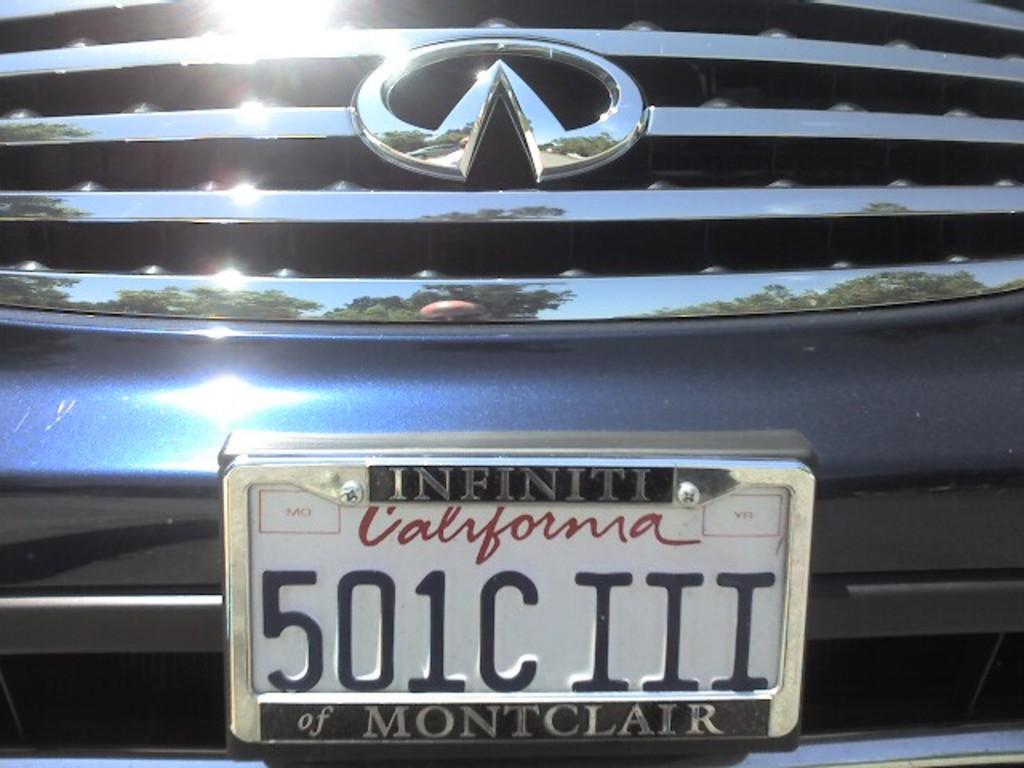Provide a one-sentence caption for the provided image. A license plate made for a car in the state of California. 